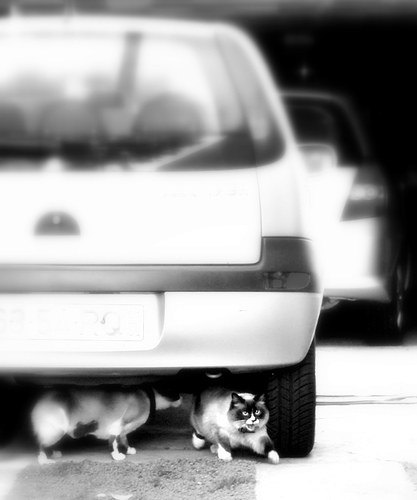How many cats are there? There are two cats visible under the car, one with distinct markings and another slightly obscured by the vehicle's tire. 